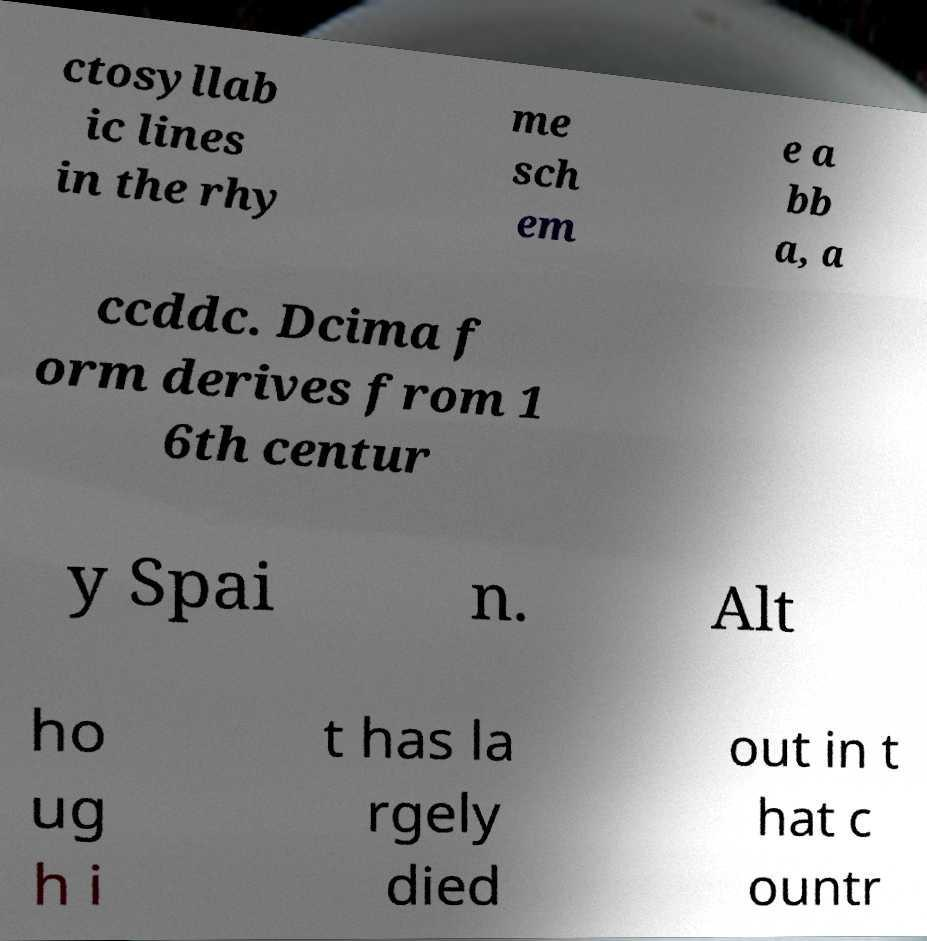I need the written content from this picture converted into text. Can you do that? ctosyllab ic lines in the rhy me sch em e a bb a, a ccddc. Dcima f orm derives from 1 6th centur y Spai n. Alt ho ug h i t has la rgely died out in t hat c ountr 